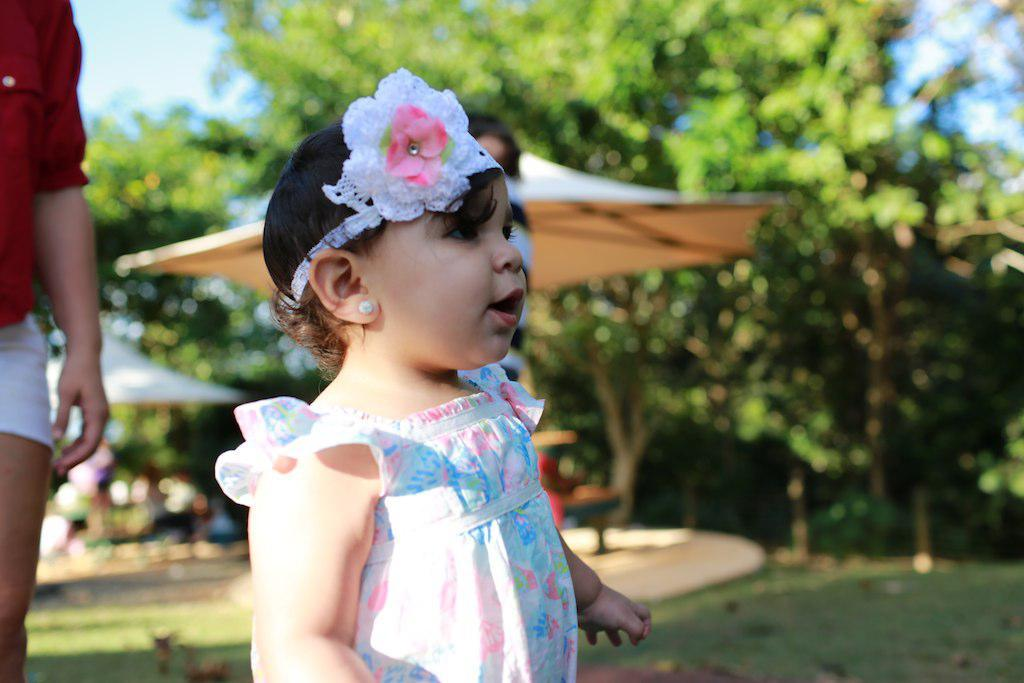What is the main subject of the image? There is a kid standing in the image. Can you describe the person behind the child? There is a person behind the child, but their specific features or actions are not mentioned in the facts. What can be seen in the background of the image? Trees, tents, and the sky are visible in the background of the image. What type of soup is being served in the image? There is no soup present in the image. Can you describe the cream used in the dish in the image? There is no dish or cream present in the image. 